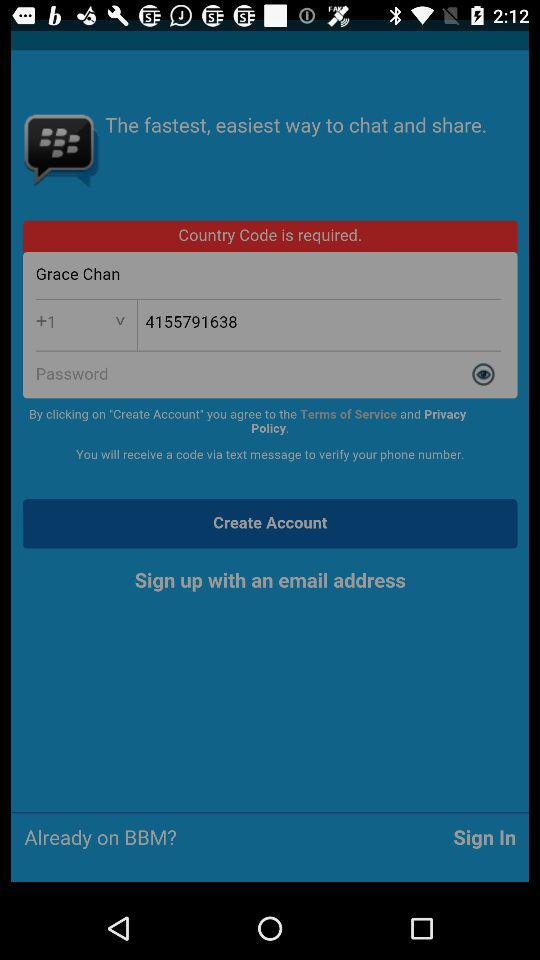How many text inputs are required to sign up for an account?
Answer the question using a single word or phrase. 2 